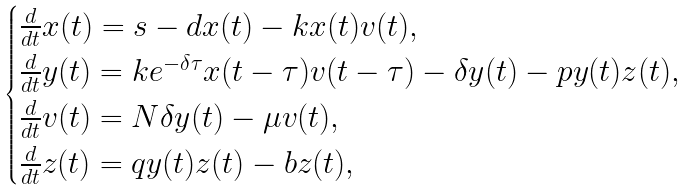Convert formula to latex. <formula><loc_0><loc_0><loc_500><loc_500>\begin{cases} \frac { d } { d t } x ( t ) = s - d x ( t ) - k x ( t ) v ( t ) , \\ \frac { d } { d t } y ( t ) = k e ^ { - \delta \tau } x ( t - \tau ) v ( t - \tau ) - \delta y ( t ) - p y ( t ) z ( t ) , \\ \frac { d } { d t } v ( t ) = N \delta y ( t ) - \mu v ( t ) , \\ \frac { d } { d t } z ( t ) = q y ( t ) z ( t ) - b z ( t ) , \end{cases}</formula> 